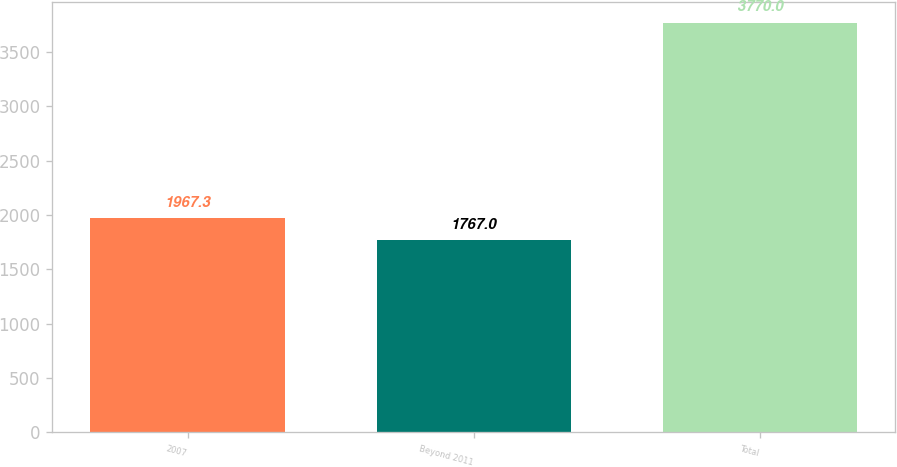Convert chart to OTSL. <chart><loc_0><loc_0><loc_500><loc_500><bar_chart><fcel>2007<fcel>Beyond 2011<fcel>Total<nl><fcel>1967.3<fcel>1767<fcel>3770<nl></chart> 